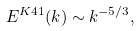Convert formula to latex. <formula><loc_0><loc_0><loc_500><loc_500>E ^ { K 4 1 } ( k ) \sim k ^ { - 5 / 3 } ,</formula> 